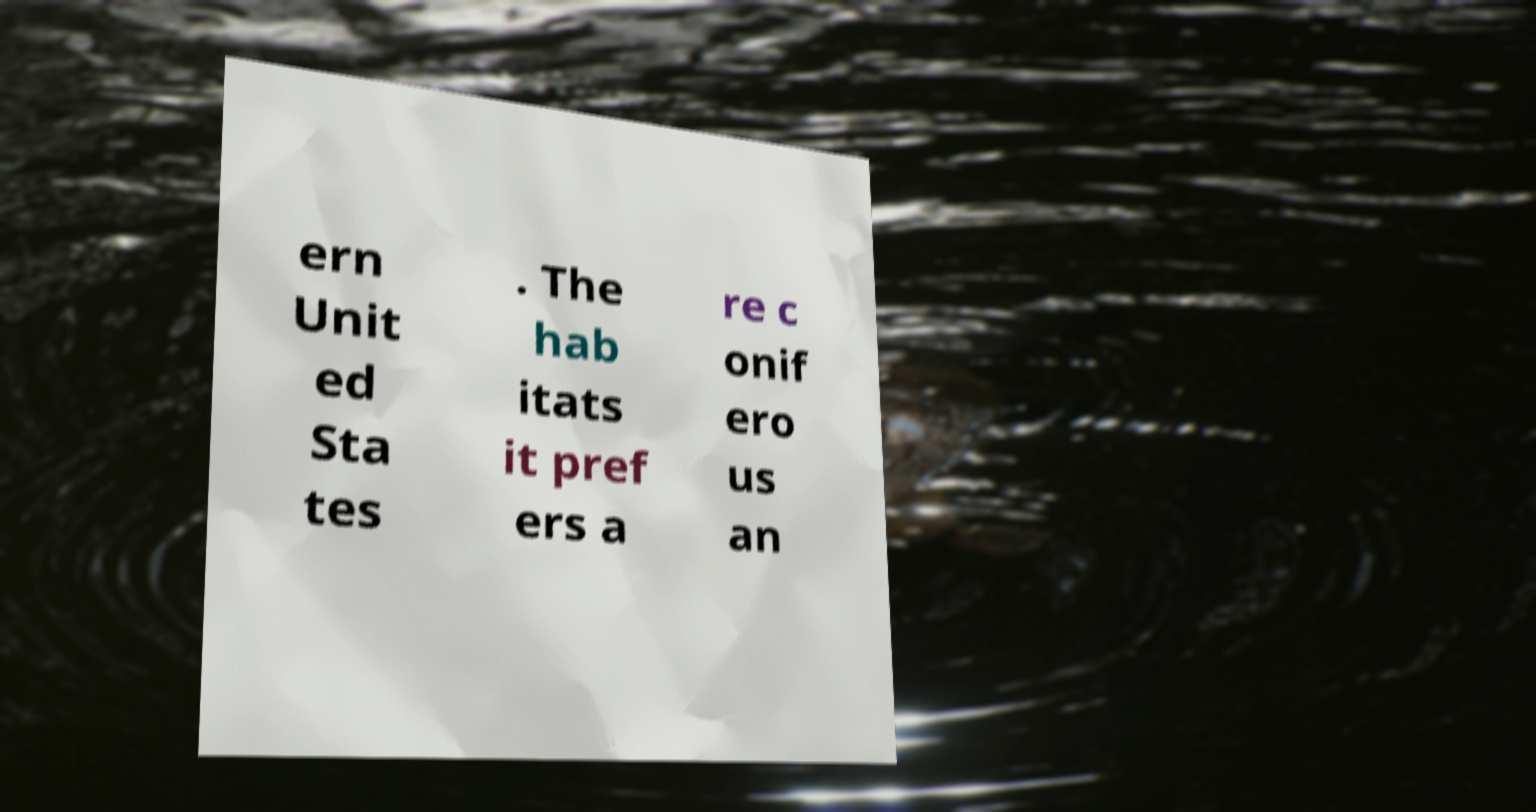Please read and relay the text visible in this image. What does it say? ern Unit ed Sta tes . The hab itats it pref ers a re c onif ero us an 